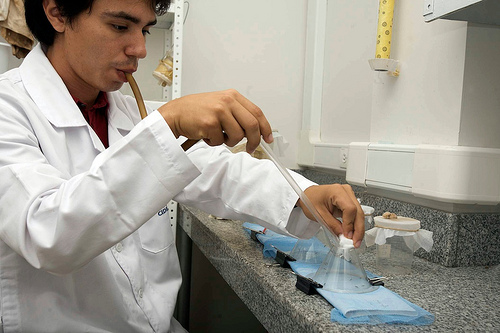<image>
Can you confirm if the yellow dispenser is to the left of the tubing? No. The yellow dispenser is not to the left of the tubing. From this viewpoint, they have a different horizontal relationship. Where is the lab jacket in relation to the countertop? Is it to the right of the countertop? No. The lab jacket is not to the right of the countertop. The horizontal positioning shows a different relationship. 